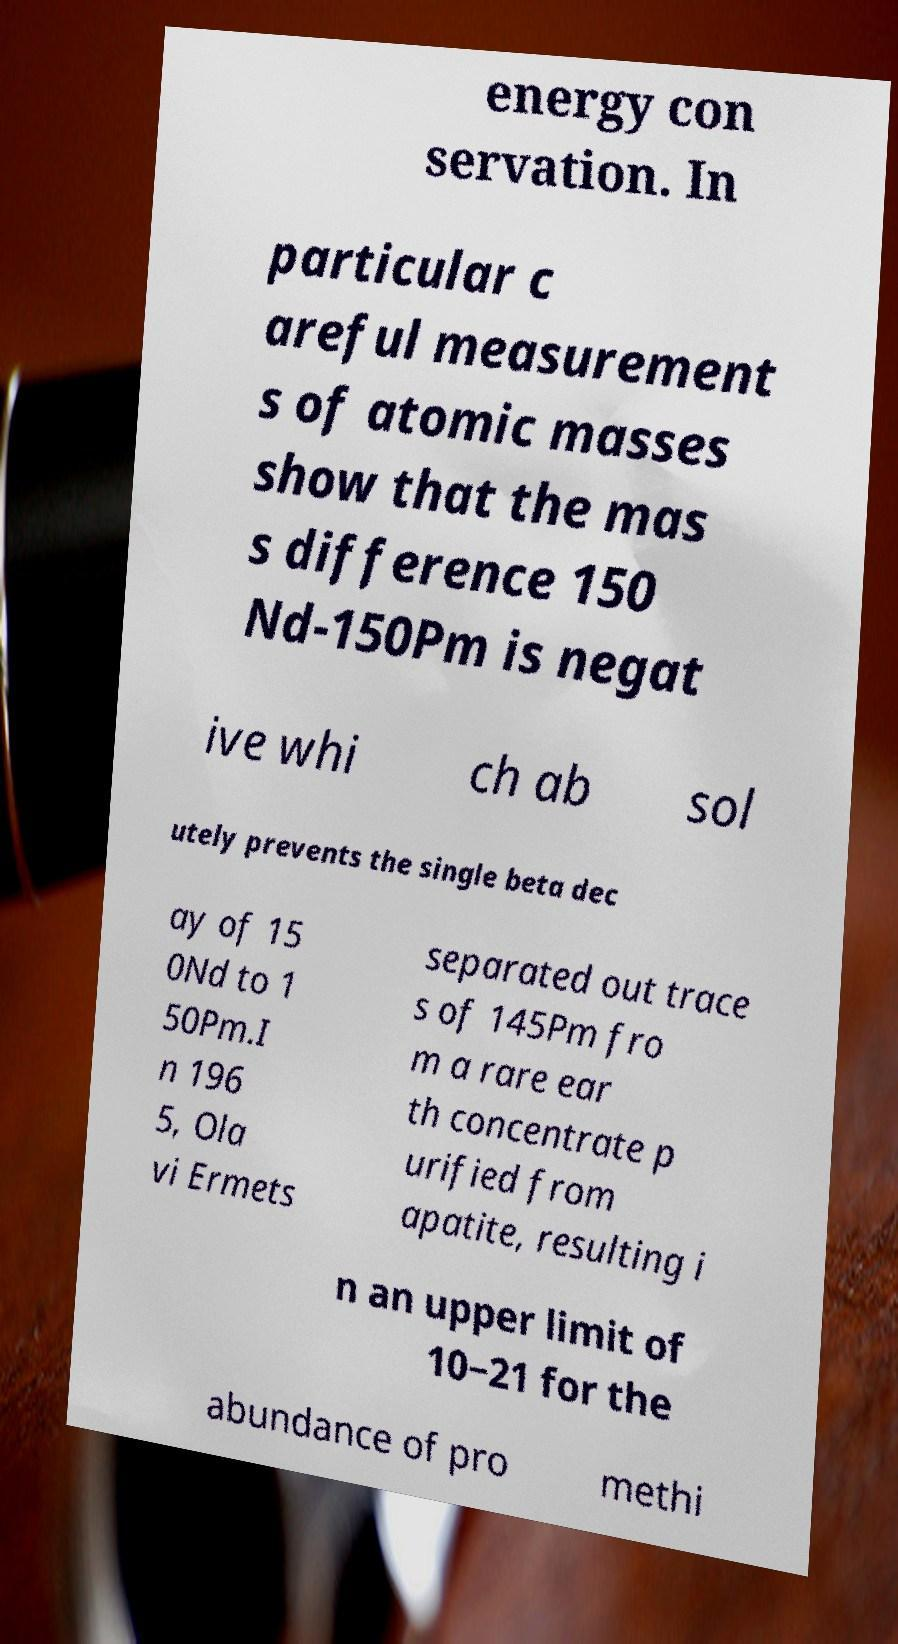For documentation purposes, I need the text within this image transcribed. Could you provide that? energy con servation. In particular c areful measurement s of atomic masses show that the mas s difference 150 Nd-150Pm is negat ive whi ch ab sol utely prevents the single beta dec ay of 15 0Nd to 1 50Pm.I n 196 5, Ola vi Ermets separated out trace s of 145Pm fro m a rare ear th concentrate p urified from apatite, resulting i n an upper limit of 10−21 for the abundance of pro methi 